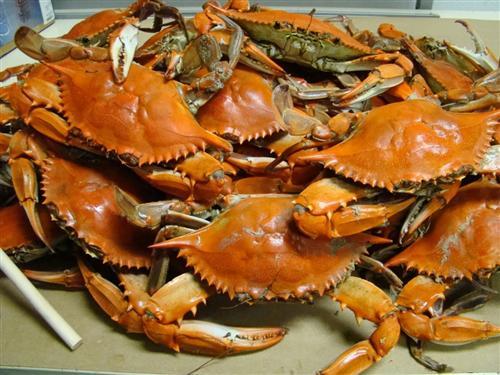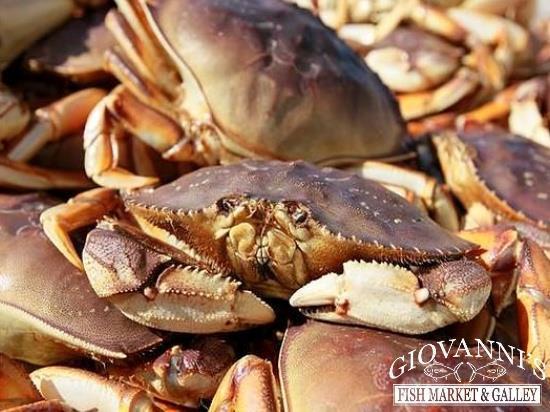The first image is the image on the left, the second image is the image on the right. Examine the images to the left and right. Is the description "In one image, a person's hand can be seen holding a single large crab with its legs curled in front." accurate? Answer yes or no. No. The first image is the image on the left, the second image is the image on the right. Given the left and right images, does the statement "The image on the right shows red crabs on top of vegetables including corn." hold true? Answer yes or no. No. 